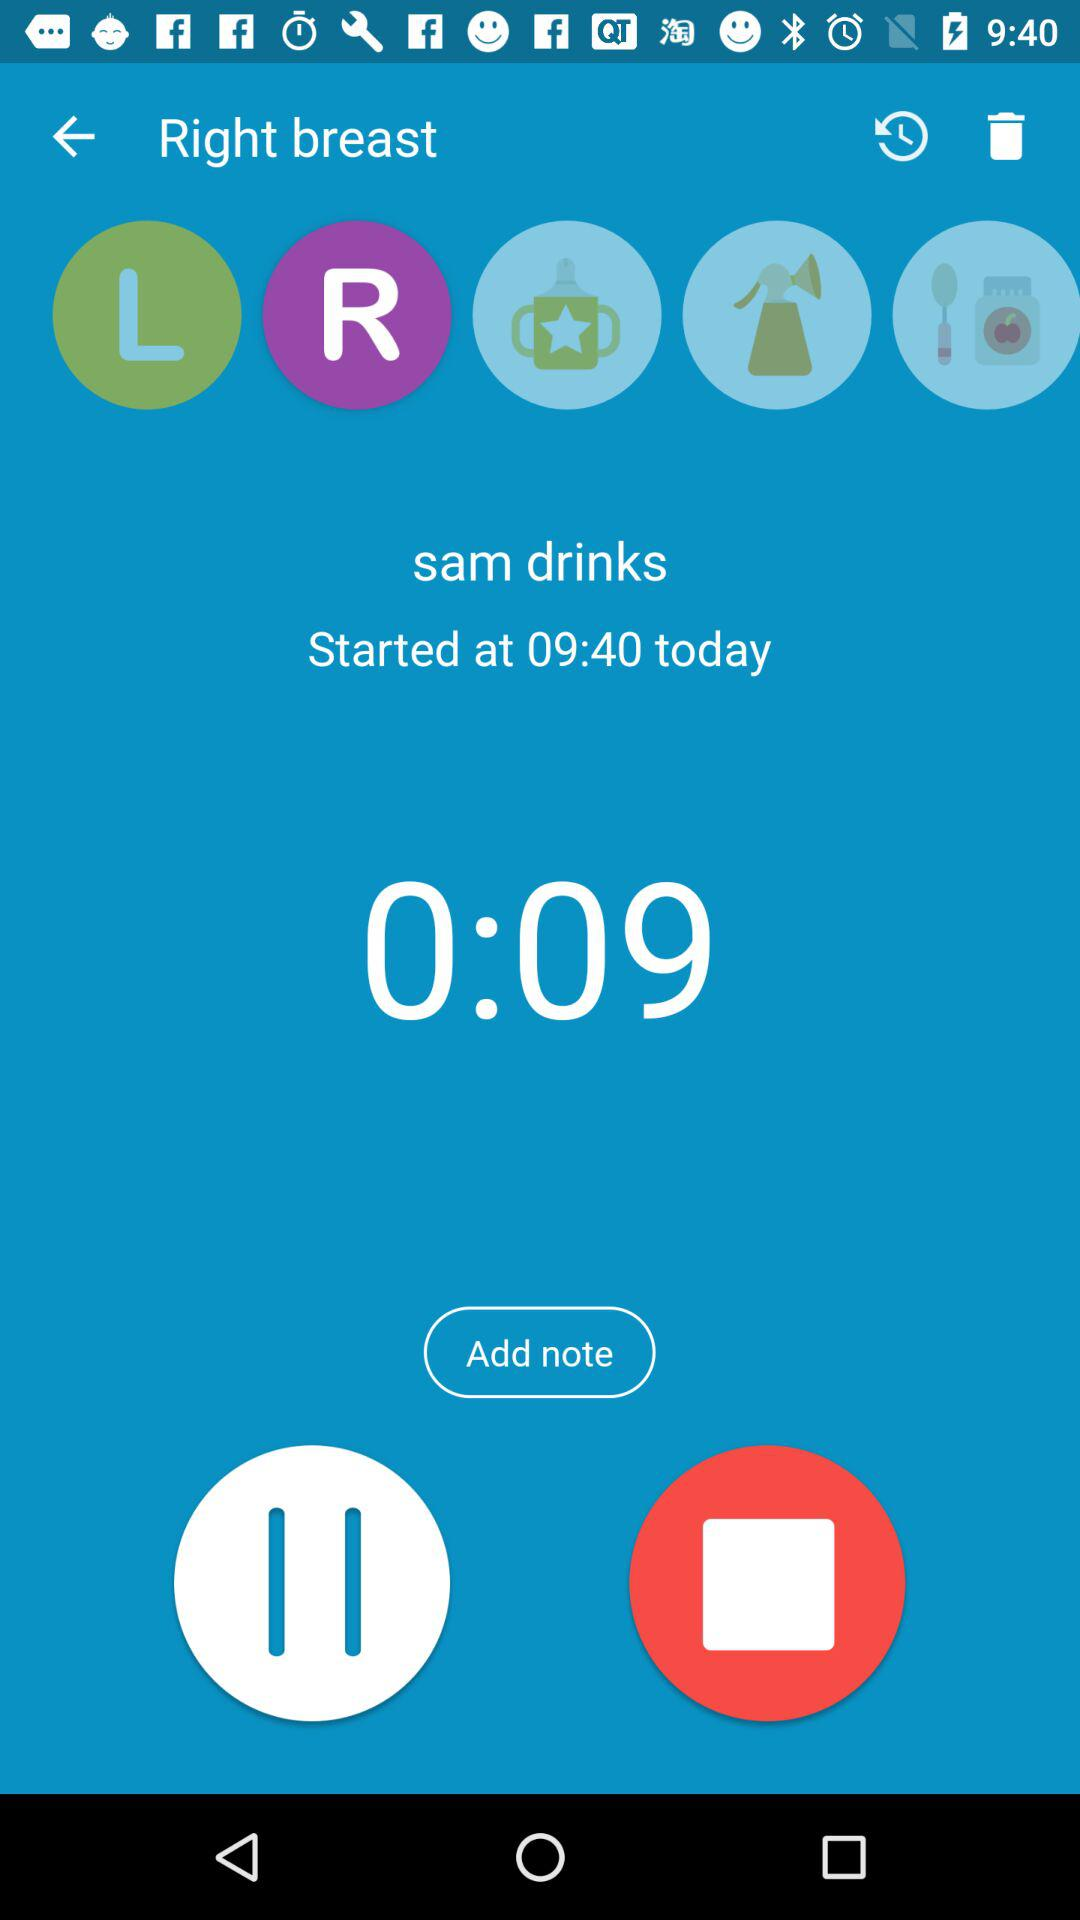What time does "sam drinks" start? The "sam drinks" start at 09:40. 